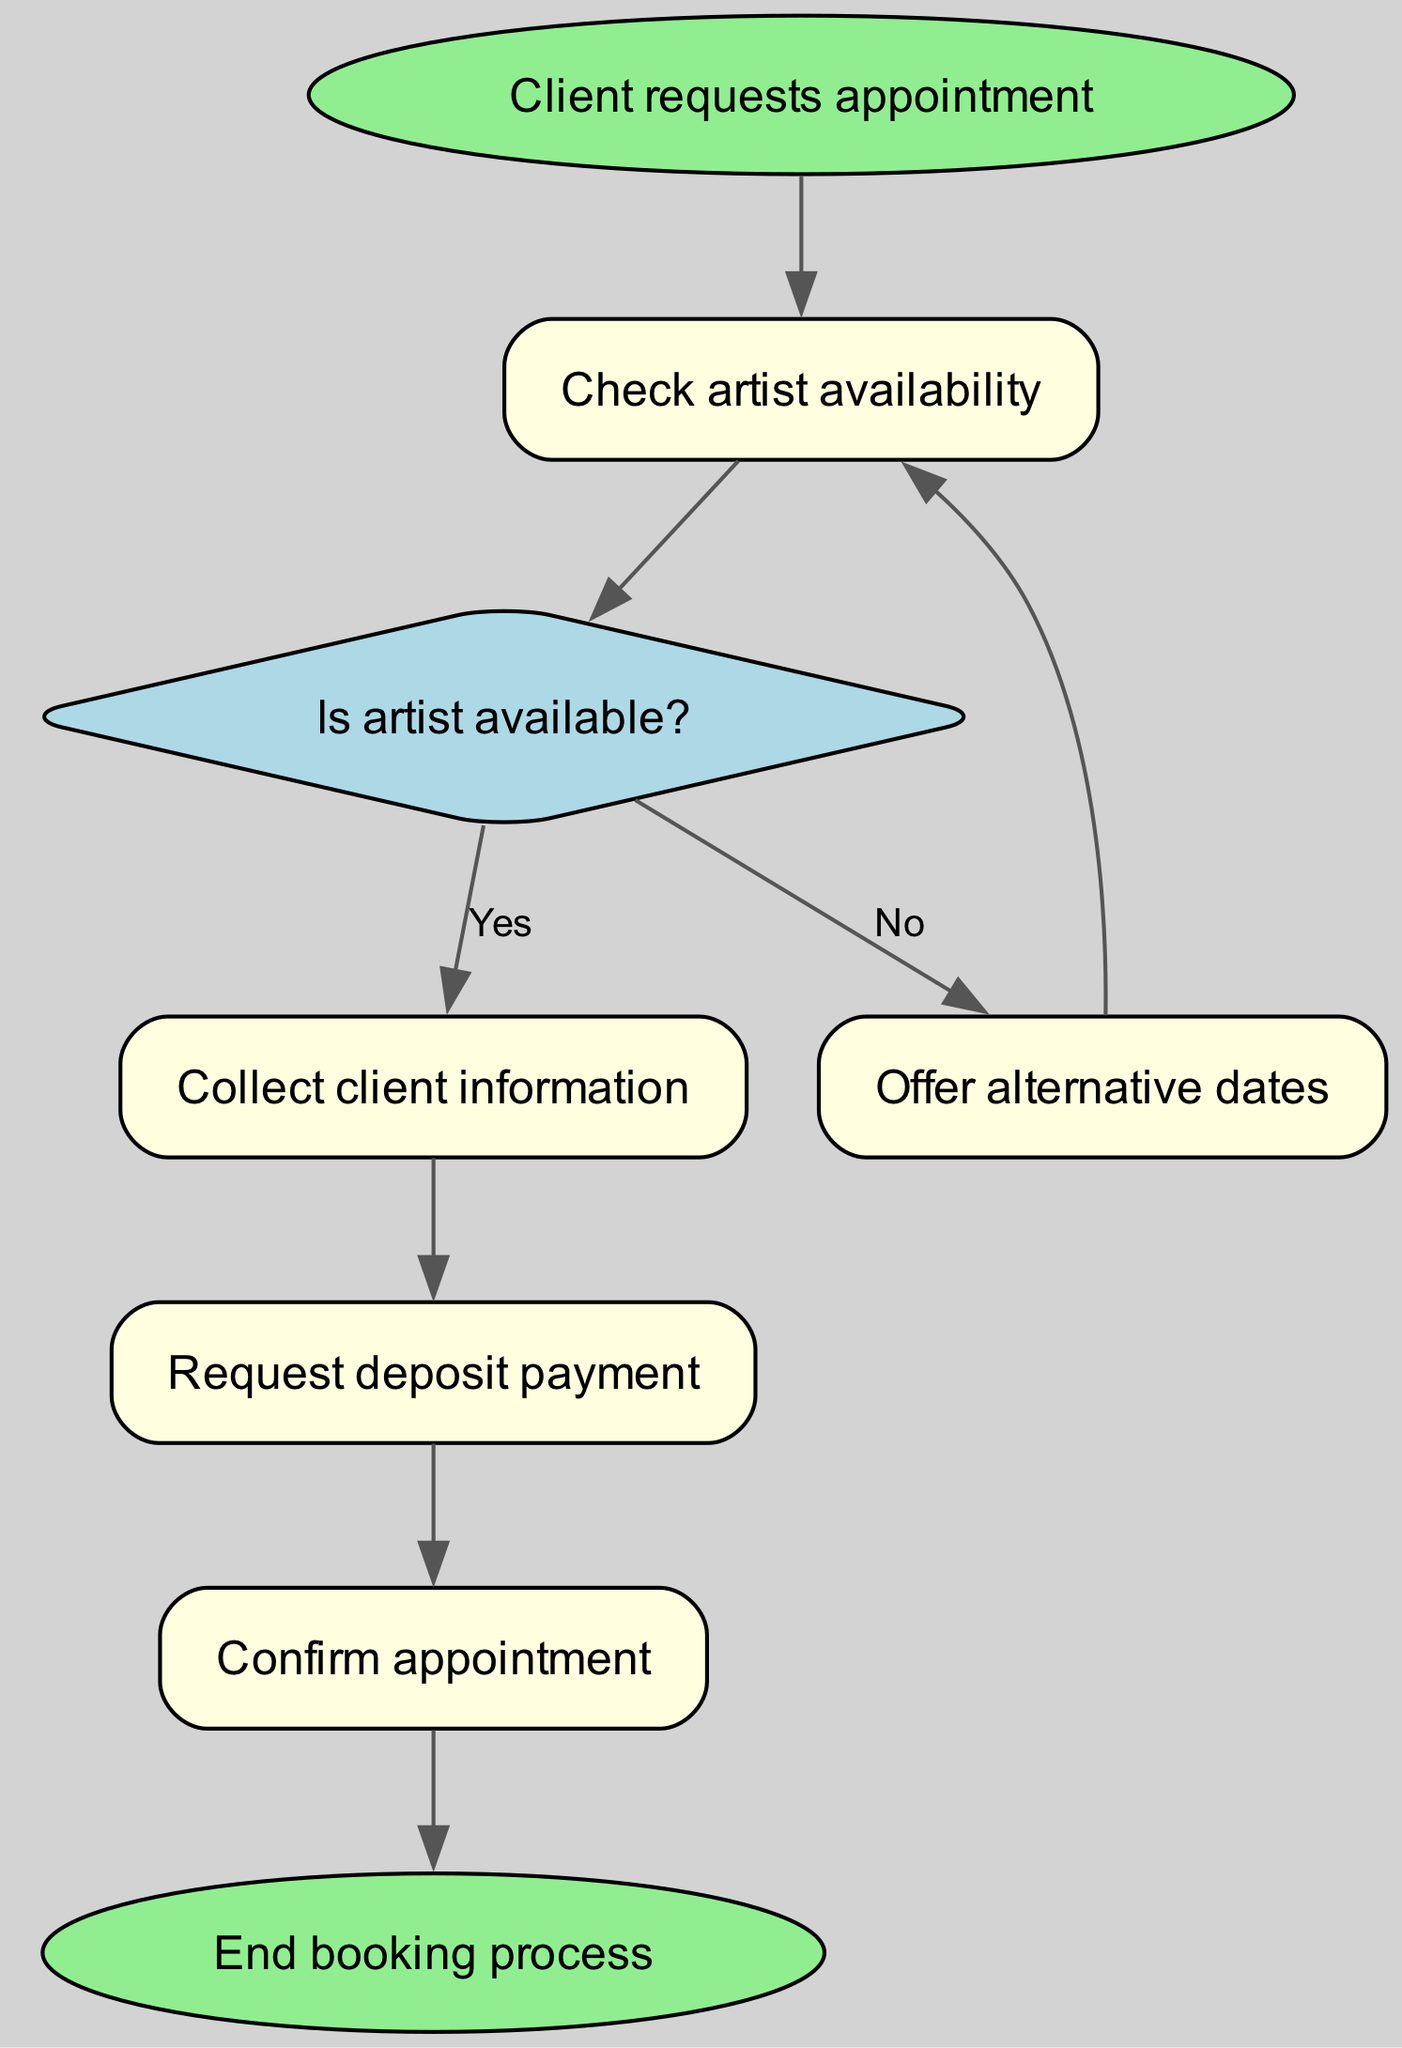What is the first step in the client booking process? The first node in the diagram is labeled "Client requests appointment," indicating that this is the initial action taken by the client.
Answer: Client requests appointment How many nodes are there in this flowchart? By counting each unique entry in the nodes section, we find that there are a total of seven nodes present in the diagram.
Answer: 7 What happens if the artist is not available? According to the flowchart, if the artist is not available, the process moves to the "Offer alternative dates" node instead of proceeding to confirm the appointment.
Answer: Offer alternative dates Which node requires the collection of client information? The node labeled "Collect client information" is the step in the process where the shop collects necessary details from the client after confirming the artist's availability.
Answer: Collect client information What is the final step in the booking process? The last node in the flowchart is "End booking process," indicating the conclusion of the entire client booking and scheduling workflow.
Answer: End booking process How do we proceed after collecting client information? After the "Collect client information" node, the next step is to "Request deposit payment," indicating that obtaining a deposit follows client information collection.
Answer: Request deposit payment What decision point is shown in the flowchart? The flowchart includes a decision point represented as a diamond shape labeled "Is artist available?" this is where the workflow diverges based on the artist's availability.
Answer: Is artist available? 